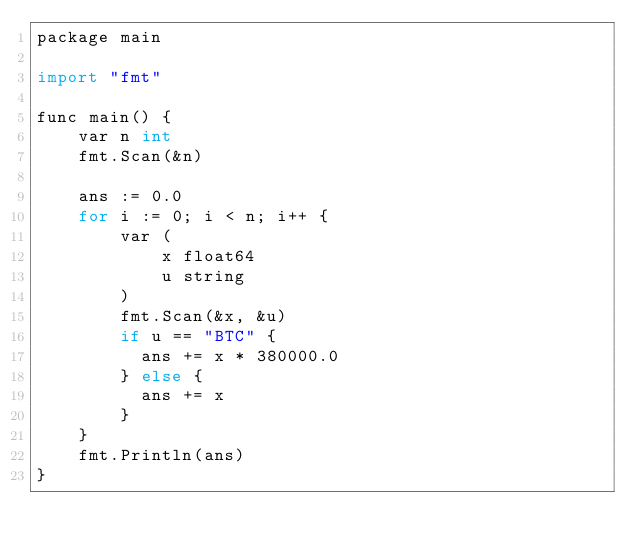Convert code to text. <code><loc_0><loc_0><loc_500><loc_500><_Python_>package main

import "fmt"

func main() {
    var n int
    fmt.Scan(&n)

    ans := 0.0
    for i := 0; i < n; i++ {
        var (
            x float64
            u string
        )
        fmt.Scan(&x, &u)
        if u == "BTC" {
          ans += x * 380000.0
        } else {
          ans += x
        }
    }
    fmt.Println(ans)
}</code> 